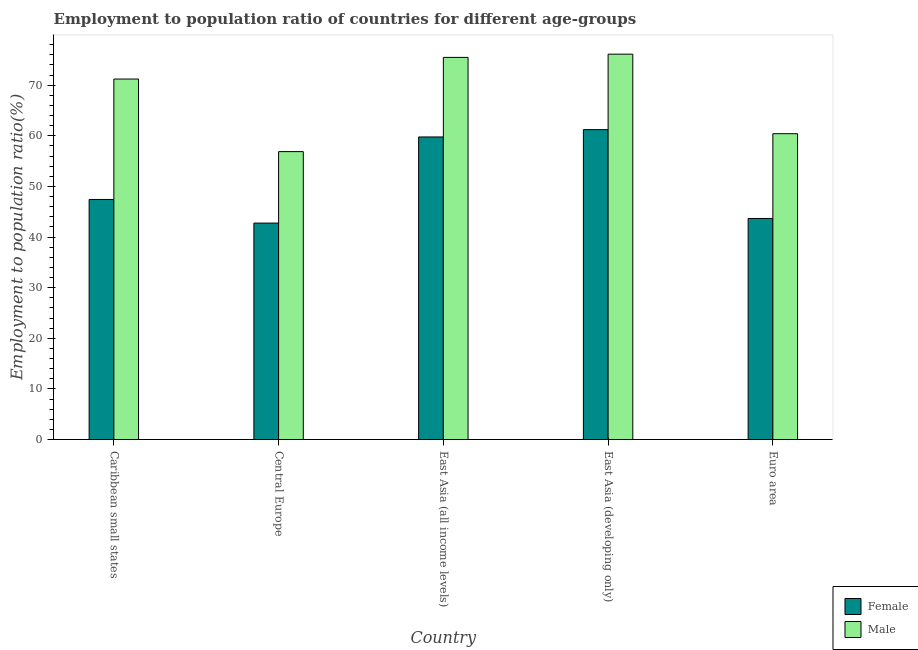How many different coloured bars are there?
Keep it short and to the point. 2. Are the number of bars on each tick of the X-axis equal?
Provide a short and direct response. Yes. How many bars are there on the 2nd tick from the left?
Keep it short and to the point. 2. How many bars are there on the 1st tick from the right?
Provide a short and direct response. 2. What is the label of the 4th group of bars from the left?
Your response must be concise. East Asia (developing only). In how many cases, is the number of bars for a given country not equal to the number of legend labels?
Your answer should be very brief. 0. What is the employment to population ratio(male) in East Asia (developing only)?
Your answer should be compact. 76.14. Across all countries, what is the maximum employment to population ratio(male)?
Keep it short and to the point. 76.14. Across all countries, what is the minimum employment to population ratio(female)?
Give a very brief answer. 42.76. In which country was the employment to population ratio(male) maximum?
Provide a short and direct response. East Asia (developing only). In which country was the employment to population ratio(male) minimum?
Your response must be concise. Central Europe. What is the total employment to population ratio(male) in the graph?
Your answer should be compact. 340.15. What is the difference between the employment to population ratio(female) in Caribbean small states and that in East Asia (developing only)?
Give a very brief answer. -13.79. What is the difference between the employment to population ratio(female) in East Asia (all income levels) and the employment to population ratio(male) in Central Europe?
Give a very brief answer. 2.9. What is the average employment to population ratio(male) per country?
Make the answer very short. 68.03. What is the difference between the employment to population ratio(male) and employment to population ratio(female) in East Asia (all income levels)?
Give a very brief answer. 15.72. In how many countries, is the employment to population ratio(male) greater than 14 %?
Make the answer very short. 5. What is the ratio of the employment to population ratio(female) in Caribbean small states to that in Central Europe?
Your answer should be very brief. 1.11. Is the difference between the employment to population ratio(female) in East Asia (all income levels) and Euro area greater than the difference between the employment to population ratio(male) in East Asia (all income levels) and Euro area?
Your answer should be compact. Yes. What is the difference between the highest and the second highest employment to population ratio(female)?
Offer a terse response. 1.45. What is the difference between the highest and the lowest employment to population ratio(male)?
Make the answer very short. 19.26. In how many countries, is the employment to population ratio(male) greater than the average employment to population ratio(male) taken over all countries?
Provide a succinct answer. 3. Is the sum of the employment to population ratio(male) in Caribbean small states and East Asia (all income levels) greater than the maximum employment to population ratio(female) across all countries?
Provide a succinct answer. Yes. What does the 2nd bar from the right in Caribbean small states represents?
Provide a succinct answer. Female. How many bars are there?
Keep it short and to the point. 10. Does the graph contain any zero values?
Make the answer very short. No. What is the title of the graph?
Keep it short and to the point. Employment to population ratio of countries for different age-groups. Does "Imports" appear as one of the legend labels in the graph?
Provide a short and direct response. No. What is the label or title of the X-axis?
Your response must be concise. Country. What is the label or title of the Y-axis?
Your answer should be very brief. Employment to population ratio(%). What is the Employment to population ratio(%) of Female in Caribbean small states?
Provide a short and direct response. 47.43. What is the Employment to population ratio(%) of Male in Caribbean small states?
Provide a succinct answer. 71.22. What is the Employment to population ratio(%) of Female in Central Europe?
Offer a very short reply. 42.76. What is the Employment to population ratio(%) in Male in Central Europe?
Ensure brevity in your answer.  56.88. What is the Employment to population ratio(%) of Female in East Asia (all income levels)?
Offer a terse response. 59.77. What is the Employment to population ratio(%) in Male in East Asia (all income levels)?
Your answer should be very brief. 75.49. What is the Employment to population ratio(%) in Female in East Asia (developing only)?
Your answer should be very brief. 61.22. What is the Employment to population ratio(%) in Male in East Asia (developing only)?
Your response must be concise. 76.14. What is the Employment to population ratio(%) of Female in Euro area?
Offer a very short reply. 43.67. What is the Employment to population ratio(%) in Male in Euro area?
Keep it short and to the point. 60.42. Across all countries, what is the maximum Employment to population ratio(%) of Female?
Your answer should be compact. 61.22. Across all countries, what is the maximum Employment to population ratio(%) in Male?
Your answer should be compact. 76.14. Across all countries, what is the minimum Employment to population ratio(%) of Female?
Your answer should be very brief. 42.76. Across all countries, what is the minimum Employment to population ratio(%) of Male?
Your answer should be very brief. 56.88. What is the total Employment to population ratio(%) of Female in the graph?
Offer a very short reply. 254.86. What is the total Employment to population ratio(%) of Male in the graph?
Keep it short and to the point. 340.15. What is the difference between the Employment to population ratio(%) of Female in Caribbean small states and that in Central Europe?
Your answer should be compact. 4.67. What is the difference between the Employment to population ratio(%) of Male in Caribbean small states and that in Central Europe?
Offer a terse response. 14.34. What is the difference between the Employment to population ratio(%) of Female in Caribbean small states and that in East Asia (all income levels)?
Your answer should be very brief. -12.35. What is the difference between the Employment to population ratio(%) of Male in Caribbean small states and that in East Asia (all income levels)?
Your response must be concise. -4.27. What is the difference between the Employment to population ratio(%) in Female in Caribbean small states and that in East Asia (developing only)?
Make the answer very short. -13.79. What is the difference between the Employment to population ratio(%) in Male in Caribbean small states and that in East Asia (developing only)?
Your answer should be very brief. -4.92. What is the difference between the Employment to population ratio(%) in Female in Caribbean small states and that in Euro area?
Ensure brevity in your answer.  3.76. What is the difference between the Employment to population ratio(%) in Male in Caribbean small states and that in Euro area?
Your response must be concise. 10.8. What is the difference between the Employment to population ratio(%) of Female in Central Europe and that in East Asia (all income levels)?
Keep it short and to the point. -17.01. What is the difference between the Employment to population ratio(%) of Male in Central Europe and that in East Asia (all income levels)?
Offer a terse response. -18.61. What is the difference between the Employment to population ratio(%) of Female in Central Europe and that in East Asia (developing only)?
Your answer should be very brief. -18.46. What is the difference between the Employment to population ratio(%) of Male in Central Europe and that in East Asia (developing only)?
Give a very brief answer. -19.26. What is the difference between the Employment to population ratio(%) in Female in Central Europe and that in Euro area?
Provide a short and direct response. -0.91. What is the difference between the Employment to population ratio(%) in Male in Central Europe and that in Euro area?
Provide a succinct answer. -3.54. What is the difference between the Employment to population ratio(%) of Female in East Asia (all income levels) and that in East Asia (developing only)?
Your response must be concise. -1.45. What is the difference between the Employment to population ratio(%) of Male in East Asia (all income levels) and that in East Asia (developing only)?
Give a very brief answer. -0.64. What is the difference between the Employment to population ratio(%) of Female in East Asia (all income levels) and that in Euro area?
Offer a terse response. 16.1. What is the difference between the Employment to population ratio(%) in Male in East Asia (all income levels) and that in Euro area?
Provide a short and direct response. 15.07. What is the difference between the Employment to population ratio(%) in Female in East Asia (developing only) and that in Euro area?
Give a very brief answer. 17.55. What is the difference between the Employment to population ratio(%) of Male in East Asia (developing only) and that in Euro area?
Your response must be concise. 15.72. What is the difference between the Employment to population ratio(%) in Female in Caribbean small states and the Employment to population ratio(%) in Male in Central Europe?
Make the answer very short. -9.45. What is the difference between the Employment to population ratio(%) of Female in Caribbean small states and the Employment to population ratio(%) of Male in East Asia (all income levels)?
Keep it short and to the point. -28.07. What is the difference between the Employment to population ratio(%) in Female in Caribbean small states and the Employment to population ratio(%) in Male in East Asia (developing only)?
Provide a succinct answer. -28.71. What is the difference between the Employment to population ratio(%) in Female in Caribbean small states and the Employment to population ratio(%) in Male in Euro area?
Your answer should be very brief. -12.99. What is the difference between the Employment to population ratio(%) of Female in Central Europe and the Employment to population ratio(%) of Male in East Asia (all income levels)?
Keep it short and to the point. -32.73. What is the difference between the Employment to population ratio(%) in Female in Central Europe and the Employment to population ratio(%) in Male in East Asia (developing only)?
Give a very brief answer. -33.38. What is the difference between the Employment to population ratio(%) of Female in Central Europe and the Employment to population ratio(%) of Male in Euro area?
Keep it short and to the point. -17.66. What is the difference between the Employment to population ratio(%) in Female in East Asia (all income levels) and the Employment to population ratio(%) in Male in East Asia (developing only)?
Your answer should be very brief. -16.36. What is the difference between the Employment to population ratio(%) of Female in East Asia (all income levels) and the Employment to population ratio(%) of Male in Euro area?
Keep it short and to the point. -0.65. What is the difference between the Employment to population ratio(%) in Female in East Asia (developing only) and the Employment to population ratio(%) in Male in Euro area?
Provide a short and direct response. 0.8. What is the average Employment to population ratio(%) in Female per country?
Offer a terse response. 50.97. What is the average Employment to population ratio(%) of Male per country?
Provide a succinct answer. 68.03. What is the difference between the Employment to population ratio(%) of Female and Employment to population ratio(%) of Male in Caribbean small states?
Your response must be concise. -23.79. What is the difference between the Employment to population ratio(%) of Female and Employment to population ratio(%) of Male in Central Europe?
Provide a short and direct response. -14.12. What is the difference between the Employment to population ratio(%) of Female and Employment to population ratio(%) of Male in East Asia (all income levels)?
Keep it short and to the point. -15.72. What is the difference between the Employment to population ratio(%) in Female and Employment to population ratio(%) in Male in East Asia (developing only)?
Ensure brevity in your answer.  -14.91. What is the difference between the Employment to population ratio(%) in Female and Employment to population ratio(%) in Male in Euro area?
Ensure brevity in your answer.  -16.75. What is the ratio of the Employment to population ratio(%) in Female in Caribbean small states to that in Central Europe?
Make the answer very short. 1.11. What is the ratio of the Employment to population ratio(%) in Male in Caribbean small states to that in Central Europe?
Your answer should be very brief. 1.25. What is the ratio of the Employment to population ratio(%) in Female in Caribbean small states to that in East Asia (all income levels)?
Your answer should be very brief. 0.79. What is the ratio of the Employment to population ratio(%) of Male in Caribbean small states to that in East Asia (all income levels)?
Provide a succinct answer. 0.94. What is the ratio of the Employment to population ratio(%) of Female in Caribbean small states to that in East Asia (developing only)?
Ensure brevity in your answer.  0.77. What is the ratio of the Employment to population ratio(%) in Male in Caribbean small states to that in East Asia (developing only)?
Ensure brevity in your answer.  0.94. What is the ratio of the Employment to population ratio(%) of Female in Caribbean small states to that in Euro area?
Provide a succinct answer. 1.09. What is the ratio of the Employment to population ratio(%) of Male in Caribbean small states to that in Euro area?
Keep it short and to the point. 1.18. What is the ratio of the Employment to population ratio(%) in Female in Central Europe to that in East Asia (all income levels)?
Offer a very short reply. 0.72. What is the ratio of the Employment to population ratio(%) in Male in Central Europe to that in East Asia (all income levels)?
Your answer should be very brief. 0.75. What is the ratio of the Employment to population ratio(%) in Female in Central Europe to that in East Asia (developing only)?
Your response must be concise. 0.7. What is the ratio of the Employment to population ratio(%) in Male in Central Europe to that in East Asia (developing only)?
Provide a short and direct response. 0.75. What is the ratio of the Employment to population ratio(%) of Female in Central Europe to that in Euro area?
Provide a succinct answer. 0.98. What is the ratio of the Employment to population ratio(%) in Male in Central Europe to that in Euro area?
Keep it short and to the point. 0.94. What is the ratio of the Employment to population ratio(%) of Female in East Asia (all income levels) to that in East Asia (developing only)?
Provide a succinct answer. 0.98. What is the ratio of the Employment to population ratio(%) in Male in East Asia (all income levels) to that in East Asia (developing only)?
Your answer should be very brief. 0.99. What is the ratio of the Employment to population ratio(%) in Female in East Asia (all income levels) to that in Euro area?
Provide a short and direct response. 1.37. What is the ratio of the Employment to population ratio(%) of Male in East Asia (all income levels) to that in Euro area?
Make the answer very short. 1.25. What is the ratio of the Employment to population ratio(%) in Female in East Asia (developing only) to that in Euro area?
Your answer should be very brief. 1.4. What is the ratio of the Employment to population ratio(%) in Male in East Asia (developing only) to that in Euro area?
Provide a short and direct response. 1.26. What is the difference between the highest and the second highest Employment to population ratio(%) of Female?
Keep it short and to the point. 1.45. What is the difference between the highest and the second highest Employment to population ratio(%) of Male?
Offer a very short reply. 0.64. What is the difference between the highest and the lowest Employment to population ratio(%) in Female?
Your response must be concise. 18.46. What is the difference between the highest and the lowest Employment to population ratio(%) in Male?
Ensure brevity in your answer.  19.26. 